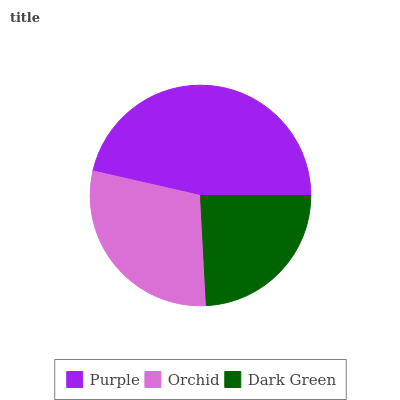Is Dark Green the minimum?
Answer yes or no. Yes. Is Purple the maximum?
Answer yes or no. Yes. Is Orchid the minimum?
Answer yes or no. No. Is Orchid the maximum?
Answer yes or no. No. Is Purple greater than Orchid?
Answer yes or no. Yes. Is Orchid less than Purple?
Answer yes or no. Yes. Is Orchid greater than Purple?
Answer yes or no. No. Is Purple less than Orchid?
Answer yes or no. No. Is Orchid the high median?
Answer yes or no. Yes. Is Orchid the low median?
Answer yes or no. Yes. Is Dark Green the high median?
Answer yes or no. No. Is Purple the low median?
Answer yes or no. No. 